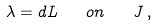Convert formula to latex. <formula><loc_0><loc_0><loc_500><loc_500>\lambda = d L \quad o n \quad J \, ,</formula> 